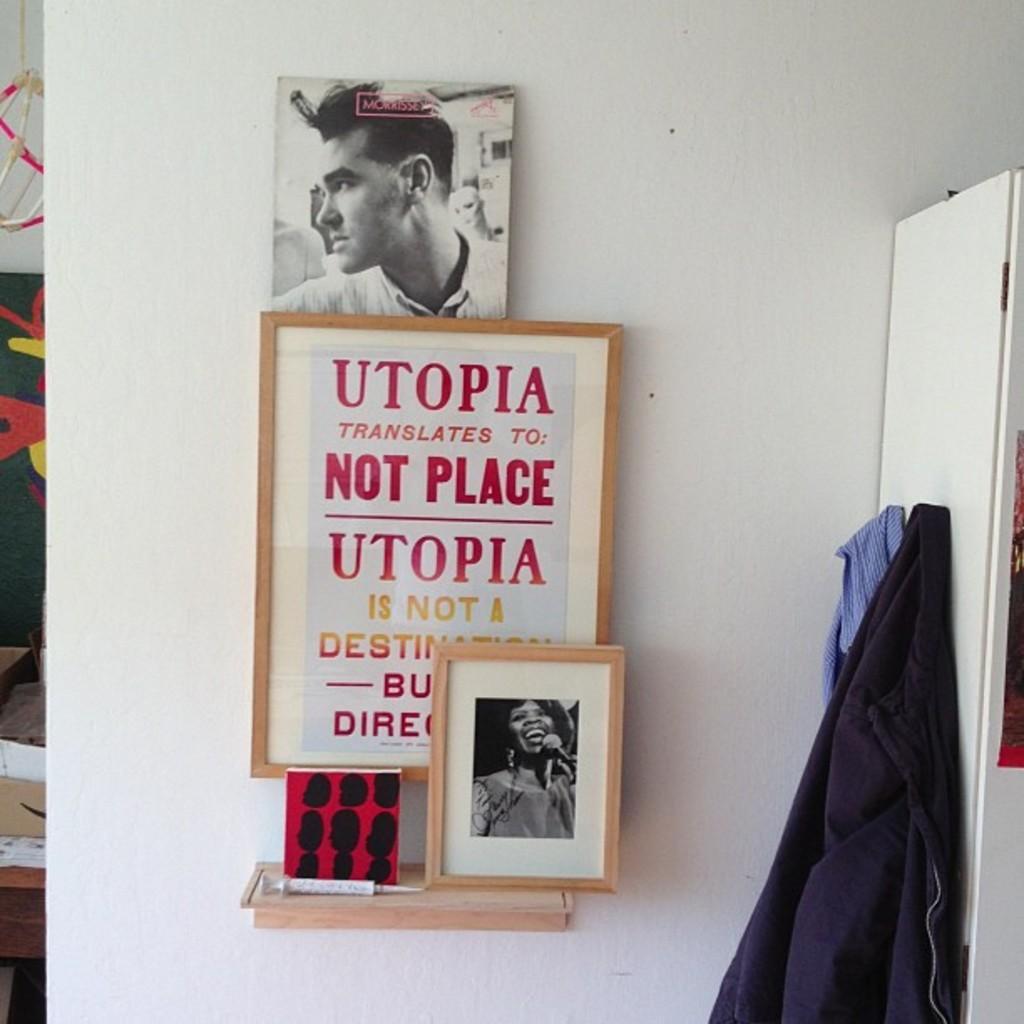Describe this image in one or two sentences. In the image we can see there are photo frames kept on the wall and there is a black and white photo of a man kept on the wall. There are two shirts hanged to the pin on the door. The wall is in white colour. 